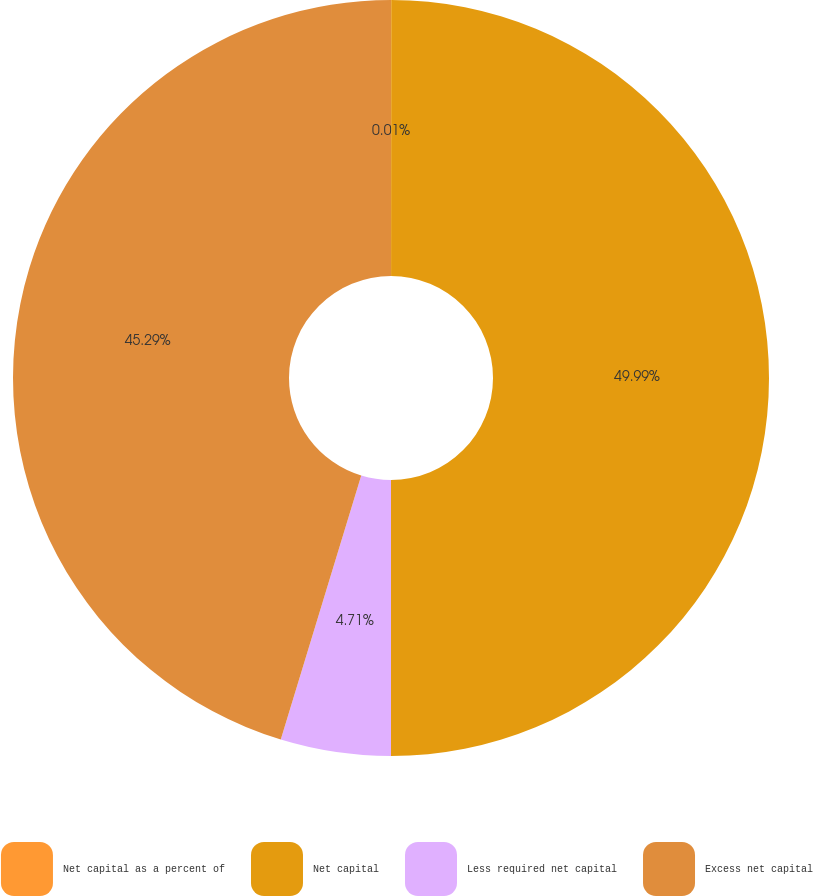<chart> <loc_0><loc_0><loc_500><loc_500><pie_chart><fcel>Net capital as a percent of<fcel>Net capital<fcel>Less required net capital<fcel>Excess net capital<nl><fcel>0.01%<fcel>49.99%<fcel>4.71%<fcel>45.29%<nl></chart> 